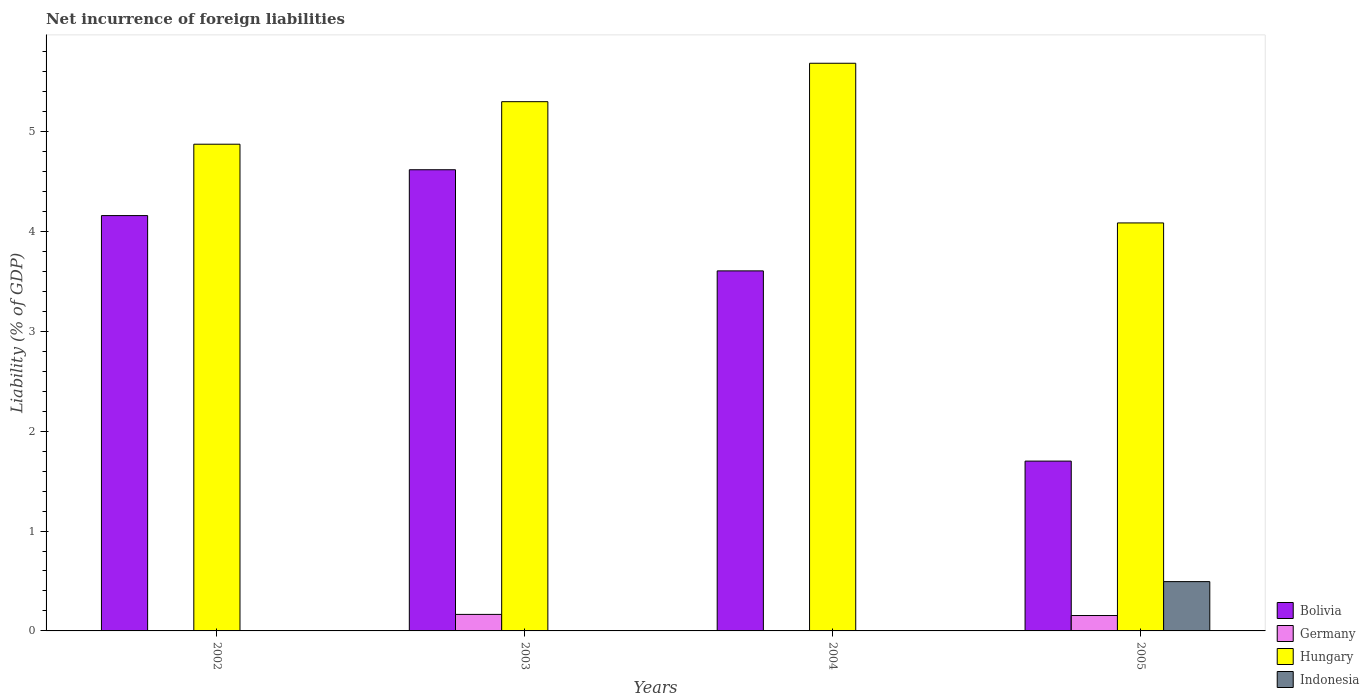How many different coloured bars are there?
Offer a terse response. 4. Are the number of bars per tick equal to the number of legend labels?
Make the answer very short. No. Are the number of bars on each tick of the X-axis equal?
Provide a succinct answer. No. How many bars are there on the 4th tick from the right?
Make the answer very short. 2. In how many cases, is the number of bars for a given year not equal to the number of legend labels?
Your answer should be very brief. 3. What is the net incurrence of foreign liabilities in Indonesia in 2004?
Give a very brief answer. 0. Across all years, what is the maximum net incurrence of foreign liabilities in Hungary?
Provide a succinct answer. 5.68. Across all years, what is the minimum net incurrence of foreign liabilities in Bolivia?
Offer a very short reply. 1.7. What is the total net incurrence of foreign liabilities in Indonesia in the graph?
Your answer should be very brief. 0.49. What is the difference between the net incurrence of foreign liabilities in Hungary in 2002 and that in 2003?
Provide a short and direct response. -0.43. What is the difference between the net incurrence of foreign liabilities in Hungary in 2005 and the net incurrence of foreign liabilities in Germany in 2002?
Your response must be concise. 4.08. What is the average net incurrence of foreign liabilities in Bolivia per year?
Give a very brief answer. 3.52. In the year 2005, what is the difference between the net incurrence of foreign liabilities in Indonesia and net incurrence of foreign liabilities in Bolivia?
Provide a succinct answer. -1.21. What is the ratio of the net incurrence of foreign liabilities in Bolivia in 2002 to that in 2003?
Give a very brief answer. 0.9. Is the net incurrence of foreign liabilities in Hungary in 2004 less than that in 2005?
Provide a short and direct response. No. What is the difference between the highest and the second highest net incurrence of foreign liabilities in Bolivia?
Give a very brief answer. 0.46. What is the difference between the highest and the lowest net incurrence of foreign liabilities in Indonesia?
Provide a succinct answer. 0.49. In how many years, is the net incurrence of foreign liabilities in Bolivia greater than the average net incurrence of foreign liabilities in Bolivia taken over all years?
Your response must be concise. 3. Is the sum of the net incurrence of foreign liabilities in Hungary in 2002 and 2004 greater than the maximum net incurrence of foreign liabilities in Germany across all years?
Your response must be concise. Yes. How many years are there in the graph?
Your answer should be compact. 4. What is the difference between two consecutive major ticks on the Y-axis?
Keep it short and to the point. 1. Are the values on the major ticks of Y-axis written in scientific E-notation?
Provide a short and direct response. No. Does the graph contain any zero values?
Offer a terse response. Yes. Where does the legend appear in the graph?
Offer a very short reply. Bottom right. How are the legend labels stacked?
Give a very brief answer. Vertical. What is the title of the graph?
Provide a succinct answer. Net incurrence of foreign liabilities. Does "Kuwait" appear as one of the legend labels in the graph?
Provide a succinct answer. No. What is the label or title of the Y-axis?
Ensure brevity in your answer.  Liability (% of GDP). What is the Liability (% of GDP) of Bolivia in 2002?
Make the answer very short. 4.16. What is the Liability (% of GDP) of Hungary in 2002?
Keep it short and to the point. 4.87. What is the Liability (% of GDP) of Bolivia in 2003?
Ensure brevity in your answer.  4.62. What is the Liability (% of GDP) of Germany in 2003?
Keep it short and to the point. 0.17. What is the Liability (% of GDP) of Hungary in 2003?
Give a very brief answer. 5.3. What is the Liability (% of GDP) in Bolivia in 2004?
Your answer should be very brief. 3.6. What is the Liability (% of GDP) in Hungary in 2004?
Your answer should be very brief. 5.68. What is the Liability (% of GDP) in Bolivia in 2005?
Provide a short and direct response. 1.7. What is the Liability (% of GDP) in Germany in 2005?
Your answer should be compact. 0.15. What is the Liability (% of GDP) of Hungary in 2005?
Make the answer very short. 4.08. What is the Liability (% of GDP) of Indonesia in 2005?
Provide a succinct answer. 0.49. Across all years, what is the maximum Liability (% of GDP) of Bolivia?
Ensure brevity in your answer.  4.62. Across all years, what is the maximum Liability (% of GDP) of Germany?
Provide a succinct answer. 0.17. Across all years, what is the maximum Liability (% of GDP) in Hungary?
Your response must be concise. 5.68. Across all years, what is the maximum Liability (% of GDP) of Indonesia?
Provide a short and direct response. 0.49. Across all years, what is the minimum Liability (% of GDP) in Bolivia?
Make the answer very short. 1.7. Across all years, what is the minimum Liability (% of GDP) in Hungary?
Your answer should be very brief. 4.08. What is the total Liability (% of GDP) of Bolivia in the graph?
Keep it short and to the point. 14.08. What is the total Liability (% of GDP) in Germany in the graph?
Keep it short and to the point. 0.32. What is the total Liability (% of GDP) of Hungary in the graph?
Give a very brief answer. 19.94. What is the total Liability (% of GDP) in Indonesia in the graph?
Your answer should be compact. 0.49. What is the difference between the Liability (% of GDP) in Bolivia in 2002 and that in 2003?
Provide a succinct answer. -0.46. What is the difference between the Liability (% of GDP) of Hungary in 2002 and that in 2003?
Offer a very short reply. -0.43. What is the difference between the Liability (% of GDP) in Bolivia in 2002 and that in 2004?
Give a very brief answer. 0.55. What is the difference between the Liability (% of GDP) in Hungary in 2002 and that in 2004?
Your response must be concise. -0.81. What is the difference between the Liability (% of GDP) in Bolivia in 2002 and that in 2005?
Provide a succinct answer. 2.46. What is the difference between the Liability (% of GDP) in Hungary in 2002 and that in 2005?
Provide a short and direct response. 0.79. What is the difference between the Liability (% of GDP) in Bolivia in 2003 and that in 2004?
Provide a short and direct response. 1.01. What is the difference between the Liability (% of GDP) in Hungary in 2003 and that in 2004?
Offer a very short reply. -0.38. What is the difference between the Liability (% of GDP) in Bolivia in 2003 and that in 2005?
Provide a short and direct response. 2.92. What is the difference between the Liability (% of GDP) of Germany in 2003 and that in 2005?
Your answer should be compact. 0.01. What is the difference between the Liability (% of GDP) in Hungary in 2003 and that in 2005?
Keep it short and to the point. 1.21. What is the difference between the Liability (% of GDP) of Bolivia in 2004 and that in 2005?
Your answer should be very brief. 1.9. What is the difference between the Liability (% of GDP) in Hungary in 2004 and that in 2005?
Provide a succinct answer. 1.6. What is the difference between the Liability (% of GDP) of Bolivia in 2002 and the Liability (% of GDP) of Germany in 2003?
Your answer should be very brief. 3.99. What is the difference between the Liability (% of GDP) of Bolivia in 2002 and the Liability (% of GDP) of Hungary in 2003?
Keep it short and to the point. -1.14. What is the difference between the Liability (% of GDP) in Bolivia in 2002 and the Liability (% of GDP) in Hungary in 2004?
Give a very brief answer. -1.52. What is the difference between the Liability (% of GDP) in Bolivia in 2002 and the Liability (% of GDP) in Germany in 2005?
Keep it short and to the point. 4. What is the difference between the Liability (% of GDP) of Bolivia in 2002 and the Liability (% of GDP) of Hungary in 2005?
Ensure brevity in your answer.  0.07. What is the difference between the Liability (% of GDP) in Bolivia in 2002 and the Liability (% of GDP) in Indonesia in 2005?
Provide a succinct answer. 3.66. What is the difference between the Liability (% of GDP) of Hungary in 2002 and the Liability (% of GDP) of Indonesia in 2005?
Your response must be concise. 4.38. What is the difference between the Liability (% of GDP) of Bolivia in 2003 and the Liability (% of GDP) of Hungary in 2004?
Make the answer very short. -1.07. What is the difference between the Liability (% of GDP) of Germany in 2003 and the Liability (% of GDP) of Hungary in 2004?
Give a very brief answer. -5.52. What is the difference between the Liability (% of GDP) in Bolivia in 2003 and the Liability (% of GDP) in Germany in 2005?
Give a very brief answer. 4.46. What is the difference between the Liability (% of GDP) of Bolivia in 2003 and the Liability (% of GDP) of Hungary in 2005?
Provide a succinct answer. 0.53. What is the difference between the Liability (% of GDP) in Bolivia in 2003 and the Liability (% of GDP) in Indonesia in 2005?
Make the answer very short. 4.12. What is the difference between the Liability (% of GDP) of Germany in 2003 and the Liability (% of GDP) of Hungary in 2005?
Offer a very short reply. -3.92. What is the difference between the Liability (% of GDP) in Germany in 2003 and the Liability (% of GDP) in Indonesia in 2005?
Provide a short and direct response. -0.33. What is the difference between the Liability (% of GDP) of Hungary in 2003 and the Liability (% of GDP) of Indonesia in 2005?
Your answer should be compact. 4.8. What is the difference between the Liability (% of GDP) of Bolivia in 2004 and the Liability (% of GDP) of Germany in 2005?
Ensure brevity in your answer.  3.45. What is the difference between the Liability (% of GDP) of Bolivia in 2004 and the Liability (% of GDP) of Hungary in 2005?
Give a very brief answer. -0.48. What is the difference between the Liability (% of GDP) in Bolivia in 2004 and the Liability (% of GDP) in Indonesia in 2005?
Offer a very short reply. 3.11. What is the difference between the Liability (% of GDP) of Hungary in 2004 and the Liability (% of GDP) of Indonesia in 2005?
Offer a very short reply. 5.19. What is the average Liability (% of GDP) of Bolivia per year?
Provide a short and direct response. 3.52. What is the average Liability (% of GDP) in Germany per year?
Offer a terse response. 0.08. What is the average Liability (% of GDP) in Hungary per year?
Provide a succinct answer. 4.98. What is the average Liability (% of GDP) in Indonesia per year?
Your response must be concise. 0.12. In the year 2002, what is the difference between the Liability (% of GDP) in Bolivia and Liability (% of GDP) in Hungary?
Your response must be concise. -0.71. In the year 2003, what is the difference between the Liability (% of GDP) of Bolivia and Liability (% of GDP) of Germany?
Make the answer very short. 4.45. In the year 2003, what is the difference between the Liability (% of GDP) of Bolivia and Liability (% of GDP) of Hungary?
Give a very brief answer. -0.68. In the year 2003, what is the difference between the Liability (% of GDP) in Germany and Liability (% of GDP) in Hungary?
Your answer should be compact. -5.13. In the year 2004, what is the difference between the Liability (% of GDP) of Bolivia and Liability (% of GDP) of Hungary?
Keep it short and to the point. -2.08. In the year 2005, what is the difference between the Liability (% of GDP) in Bolivia and Liability (% of GDP) in Germany?
Keep it short and to the point. 1.55. In the year 2005, what is the difference between the Liability (% of GDP) of Bolivia and Liability (% of GDP) of Hungary?
Ensure brevity in your answer.  -2.38. In the year 2005, what is the difference between the Liability (% of GDP) in Bolivia and Liability (% of GDP) in Indonesia?
Keep it short and to the point. 1.21. In the year 2005, what is the difference between the Liability (% of GDP) in Germany and Liability (% of GDP) in Hungary?
Your response must be concise. -3.93. In the year 2005, what is the difference between the Liability (% of GDP) of Germany and Liability (% of GDP) of Indonesia?
Make the answer very short. -0.34. In the year 2005, what is the difference between the Liability (% of GDP) in Hungary and Liability (% of GDP) in Indonesia?
Make the answer very short. 3.59. What is the ratio of the Liability (% of GDP) of Bolivia in 2002 to that in 2003?
Provide a short and direct response. 0.9. What is the ratio of the Liability (% of GDP) in Hungary in 2002 to that in 2003?
Ensure brevity in your answer.  0.92. What is the ratio of the Liability (% of GDP) in Bolivia in 2002 to that in 2004?
Provide a succinct answer. 1.15. What is the ratio of the Liability (% of GDP) in Hungary in 2002 to that in 2004?
Provide a short and direct response. 0.86. What is the ratio of the Liability (% of GDP) of Bolivia in 2002 to that in 2005?
Make the answer very short. 2.45. What is the ratio of the Liability (% of GDP) of Hungary in 2002 to that in 2005?
Your response must be concise. 1.19. What is the ratio of the Liability (% of GDP) of Bolivia in 2003 to that in 2004?
Your response must be concise. 1.28. What is the ratio of the Liability (% of GDP) in Hungary in 2003 to that in 2004?
Your answer should be compact. 0.93. What is the ratio of the Liability (% of GDP) in Bolivia in 2003 to that in 2005?
Make the answer very short. 2.72. What is the ratio of the Liability (% of GDP) of Germany in 2003 to that in 2005?
Offer a terse response. 1.07. What is the ratio of the Liability (% of GDP) in Hungary in 2003 to that in 2005?
Provide a succinct answer. 1.3. What is the ratio of the Liability (% of GDP) of Bolivia in 2004 to that in 2005?
Make the answer very short. 2.12. What is the ratio of the Liability (% of GDP) of Hungary in 2004 to that in 2005?
Offer a very short reply. 1.39. What is the difference between the highest and the second highest Liability (% of GDP) of Bolivia?
Offer a very short reply. 0.46. What is the difference between the highest and the second highest Liability (% of GDP) in Hungary?
Ensure brevity in your answer.  0.38. What is the difference between the highest and the lowest Liability (% of GDP) of Bolivia?
Your response must be concise. 2.92. What is the difference between the highest and the lowest Liability (% of GDP) of Germany?
Offer a terse response. 0.17. What is the difference between the highest and the lowest Liability (% of GDP) of Hungary?
Your answer should be compact. 1.6. What is the difference between the highest and the lowest Liability (% of GDP) in Indonesia?
Keep it short and to the point. 0.49. 